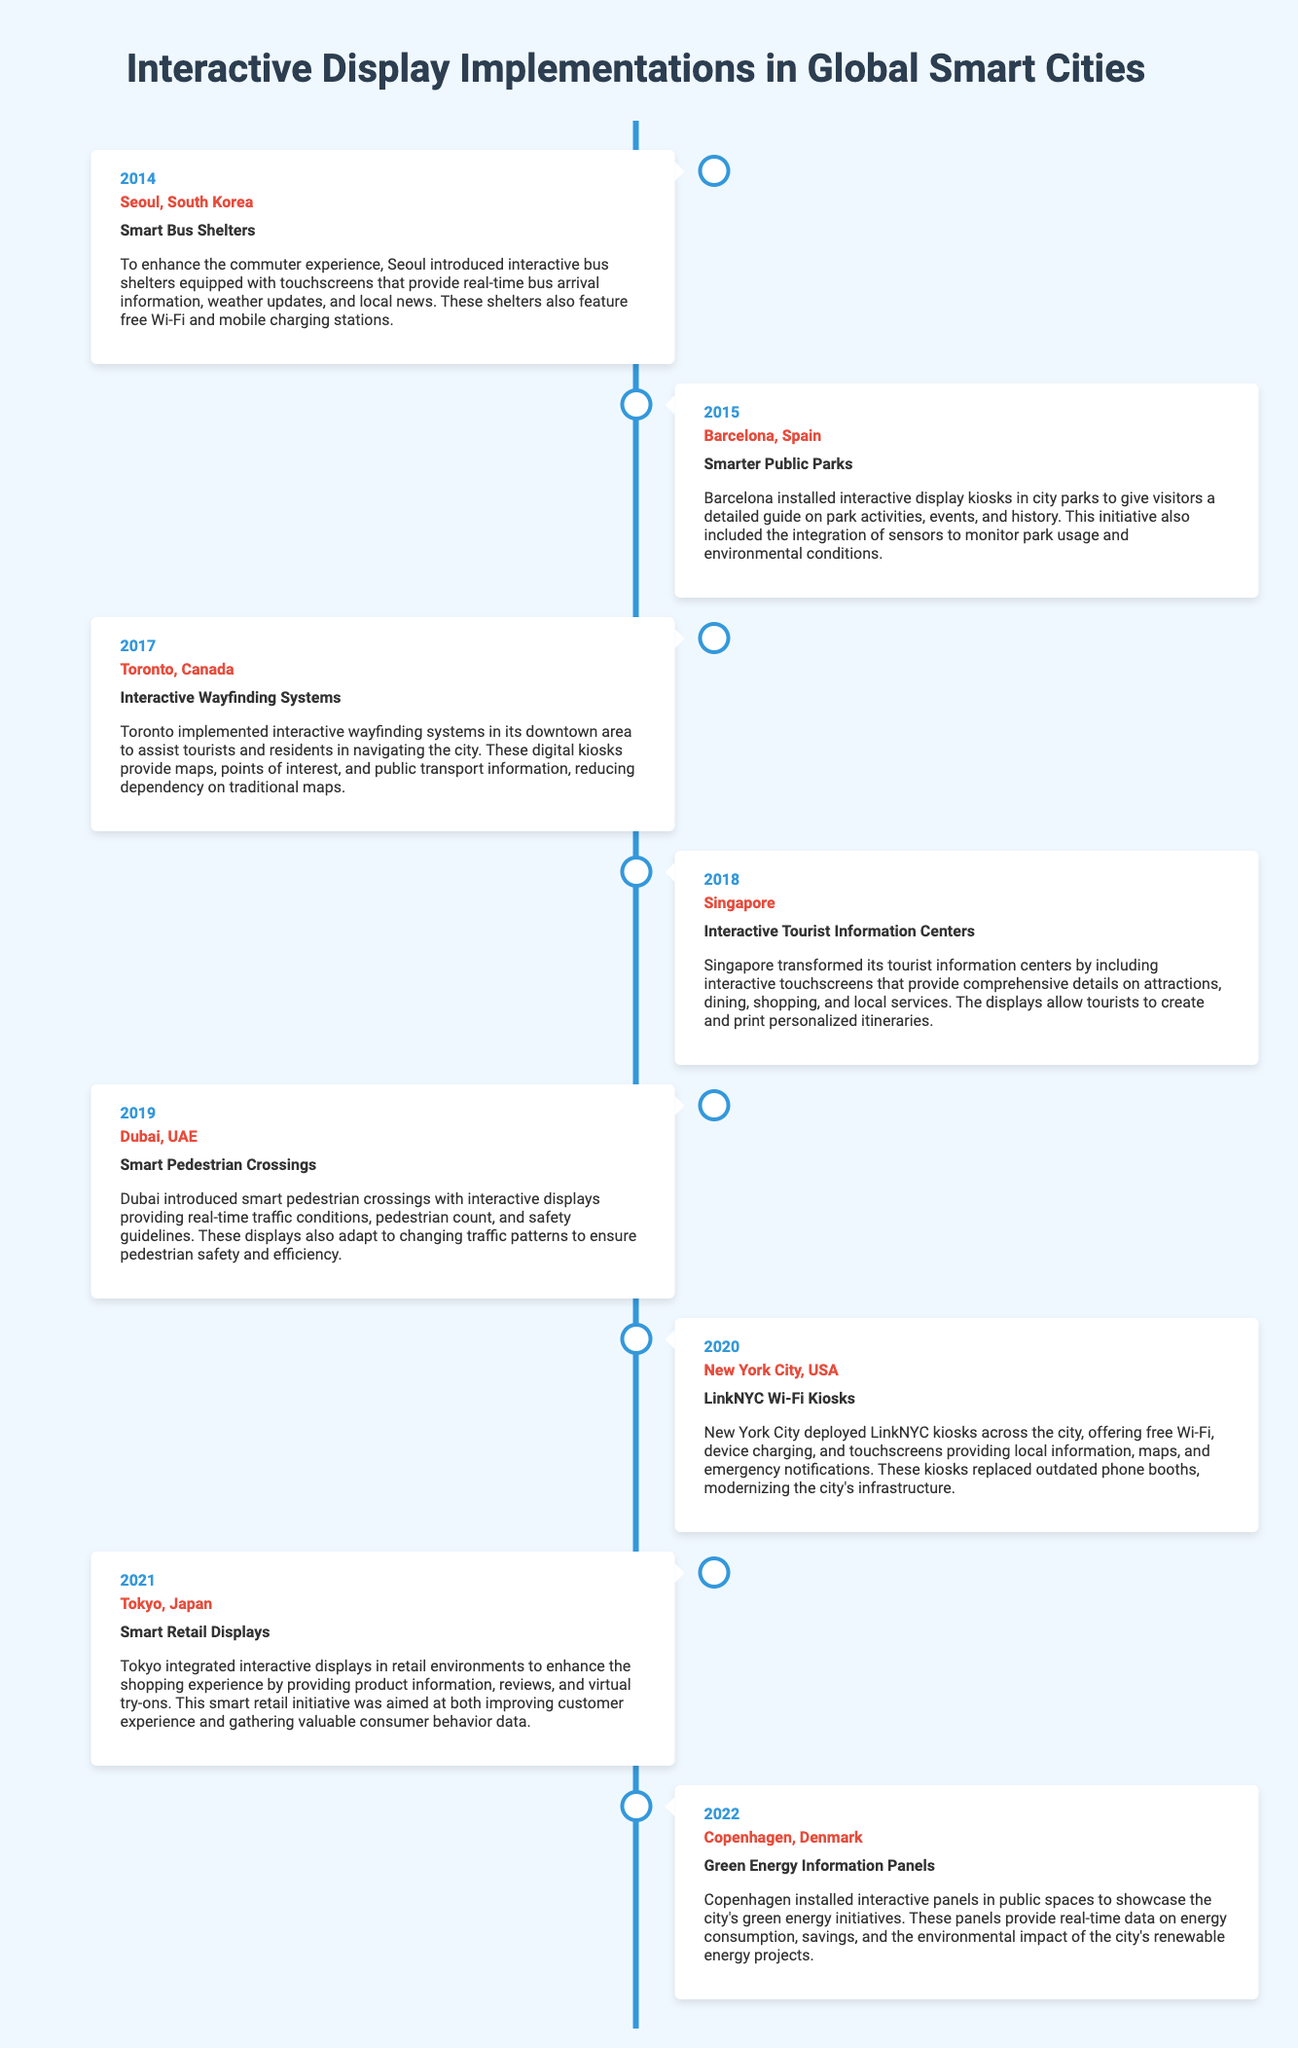What year was the first implementation? The first implementation mentioned in the timeline is in 2014, in Seoul, South Korea.
Answer: 2014 Which city implemented Smart Bus Shelters? The document states that Seoul, South Korea, introduced Smart Bus Shelters in 2014.
Answer: Seoul, South Korea What was the implementation in Barcelona in 2015? In 2015, Barcelona implemented Smarter Public Parks, which included interactive kiosks in city parks.
Answer: Smarter Public Parks How many interactive implementations are listed for the year 2019? The timeline includes one implementation for the year 2019, which is Smart Pedestrian Crossings in Dubai, UAE.
Answer: One Which city introduced LinkNYC Wi-Fi Kiosks? The document indicates that New York City deployed LinkNYC Wi-Fi Kiosks in 2020.
Answer: New York City What was a common feature in the retail displays in Tokyo? The smart retail displays in Tokyo provided product information and virtual try-ons.
Answer: Product information Which year saw the installation of Green Energy Information Panels? The timeline states that Copenhagen installed Green Energy Information Panels in 2022.
Answer: 2022 What distinguishes the timeline format from a standard list? The timeline format presents information in a chronological sequence, visually depicting the progression of implementations.
Answer: Chronological sequence How many cities are featured in the timeline up to 2022? The document lists eight different cities that implemented interactive displays from 2014 to 2022.
Answer: Eight 